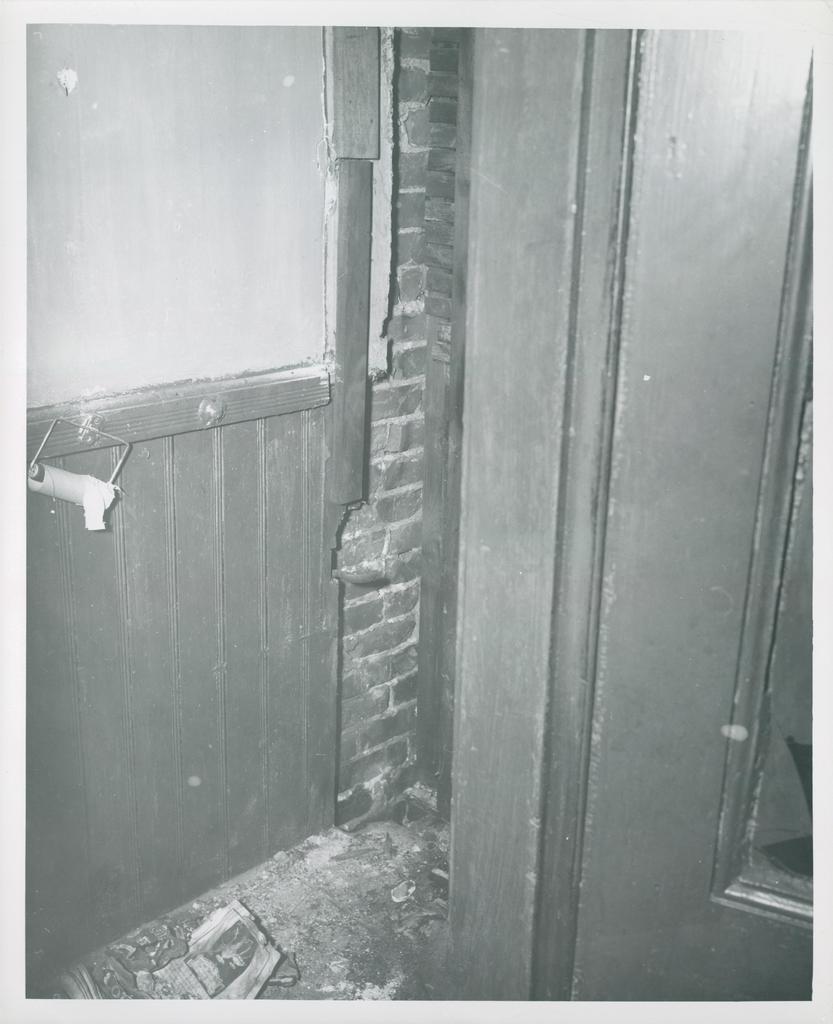Please provide a concise description of this image. In this picture we can see few doors and it is a black and white photography. 